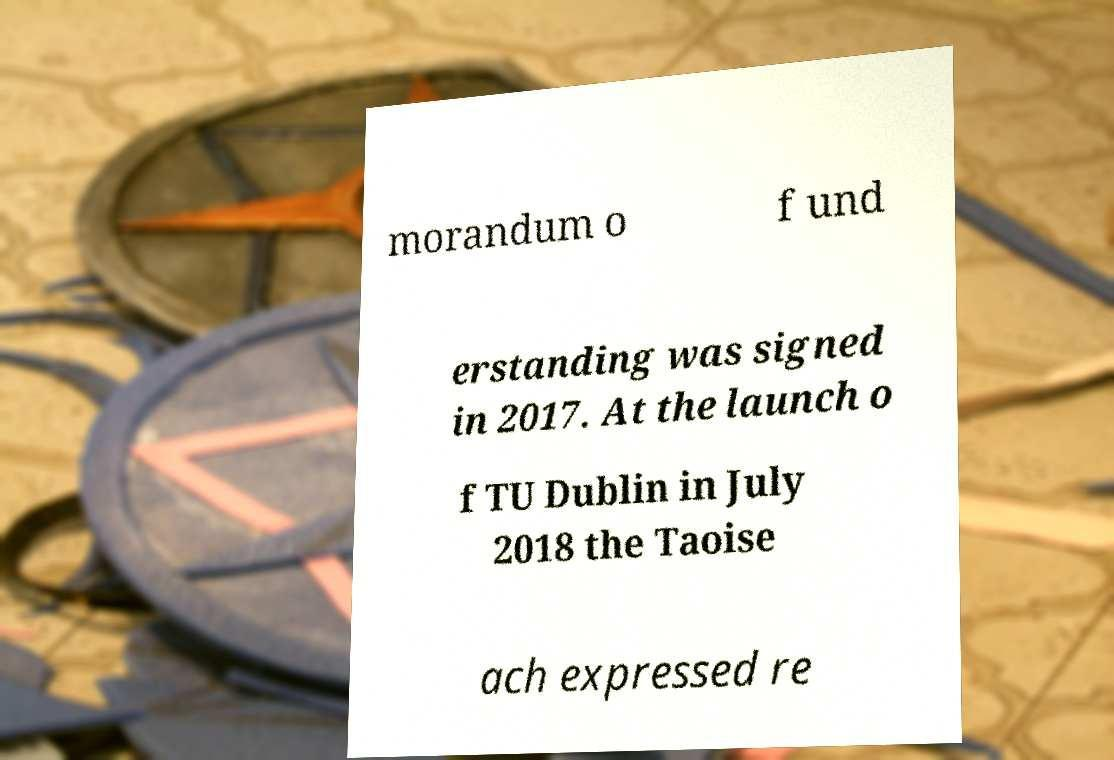Can you read and provide the text displayed in the image?This photo seems to have some interesting text. Can you extract and type it out for me? morandum o f und erstanding was signed in 2017. At the launch o f TU Dublin in July 2018 the Taoise ach expressed re 